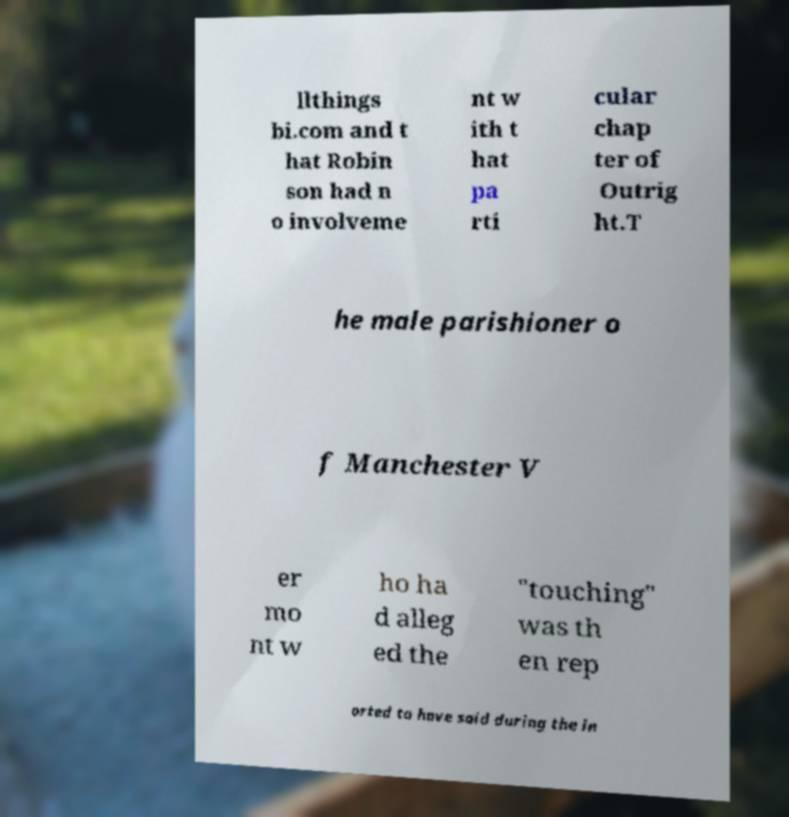Please read and relay the text visible in this image. What does it say? llthings bi.com and t hat Robin son had n o involveme nt w ith t hat pa rti cular chap ter of Outrig ht.T he male parishioner o f Manchester V er mo nt w ho ha d alleg ed the "touching" was th en rep orted to have said during the in 